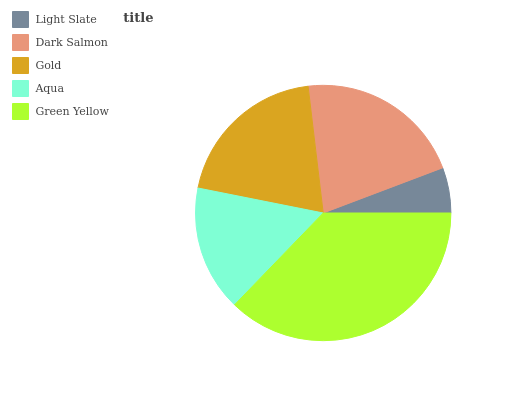Is Light Slate the minimum?
Answer yes or no. Yes. Is Green Yellow the maximum?
Answer yes or no. Yes. Is Dark Salmon the minimum?
Answer yes or no. No. Is Dark Salmon the maximum?
Answer yes or no. No. Is Dark Salmon greater than Light Slate?
Answer yes or no. Yes. Is Light Slate less than Dark Salmon?
Answer yes or no. Yes. Is Light Slate greater than Dark Salmon?
Answer yes or no. No. Is Dark Salmon less than Light Slate?
Answer yes or no. No. Is Gold the high median?
Answer yes or no. Yes. Is Gold the low median?
Answer yes or no. Yes. Is Light Slate the high median?
Answer yes or no. No. Is Dark Salmon the low median?
Answer yes or no. No. 